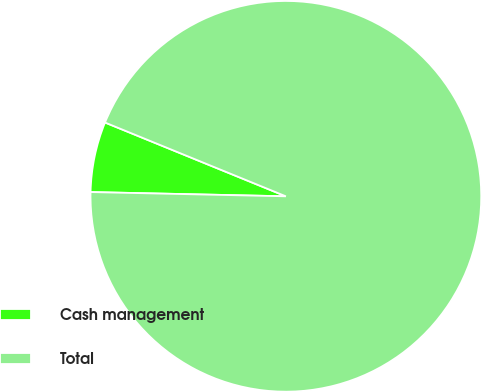<chart> <loc_0><loc_0><loc_500><loc_500><pie_chart><fcel>Cash management<fcel>Total<nl><fcel>5.82%<fcel>94.18%<nl></chart> 